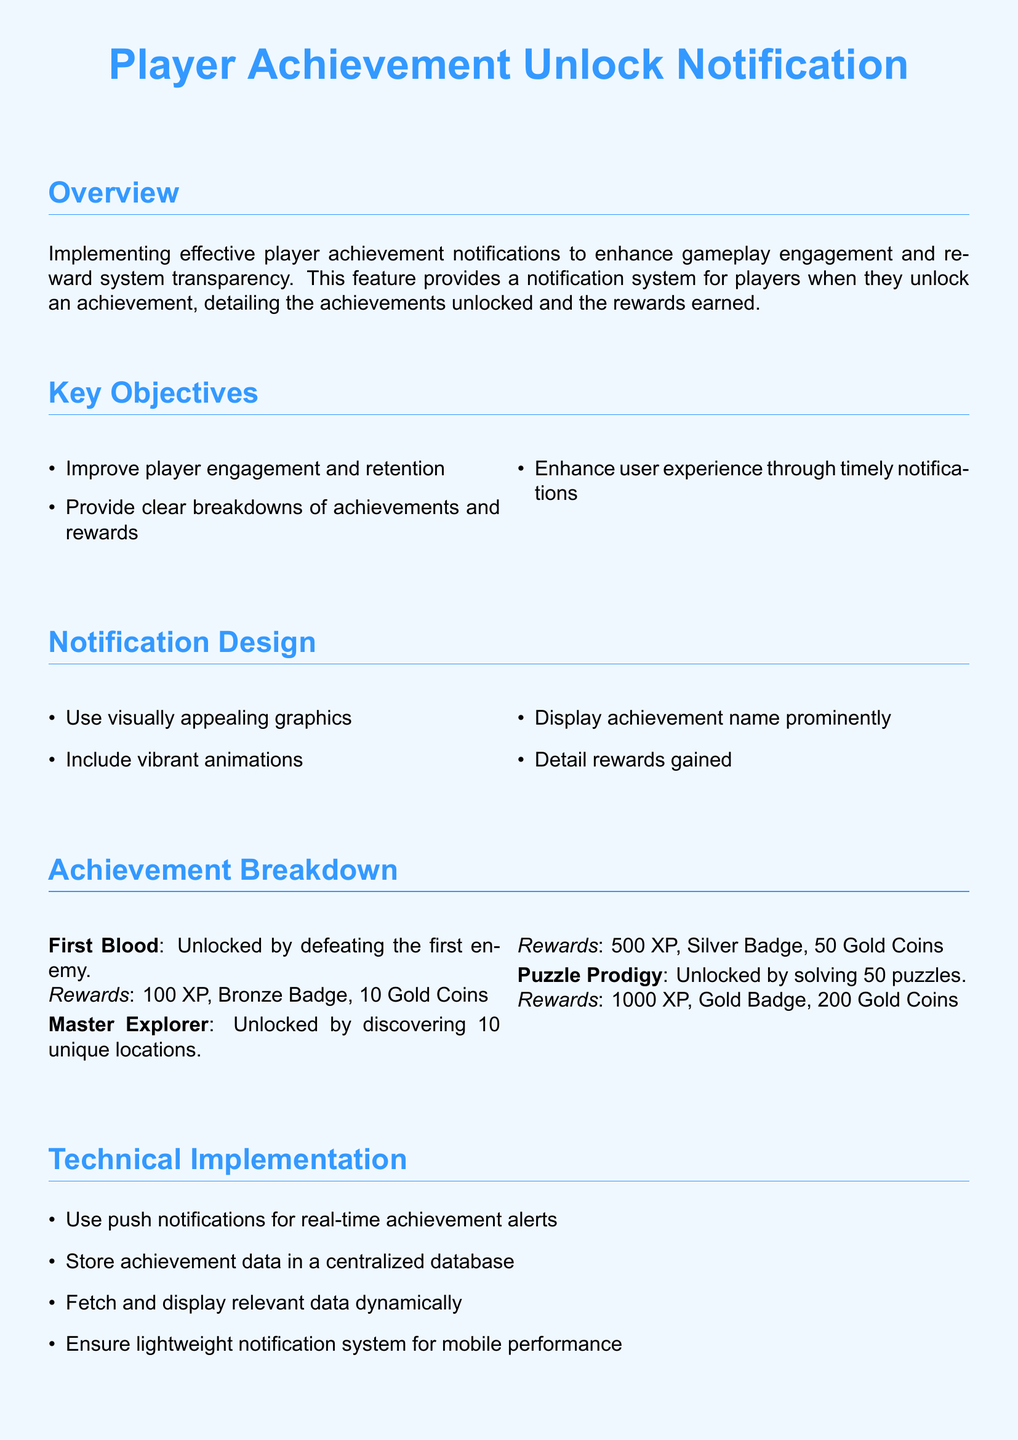What is the title of the document? The title of the document is prominently displayed at the top and indicates the main focus of the content.
Answer: Player Achievement Unlock Notification What is the achievement for discovering 10 unique locations? This question asks for a specific achievement listed in the document under Achievement Breakdown.
Answer: Master Explorer How many Gold Coins do players receive for unlocking the "First Blood" achievement? This question requires retrieving the specific reward associated with a particular achievement mentioned in the document.
Answer: 10 Gold Coins What is the XP reward for completing the "Puzzle Prodigy" achievement? This question looks for information regarding the experience points (XP) linked to a specific achievement in the document.
Answer: 1000 XP What design element is mentioned to enhance user experience? This question requires identifying a specific user experience enhancement mentioned in the notification design section of the document.
Answer: Vibrant animations How many total achievements are detailed in the Achievement Breakdown? This question involves counting the individual achievements listed under the Achievement Breakdown section.
Answer: 3 What type of notification system is recommended for real-time achievement alerts? This question asks for the specific type of system suggested in the technical implementation section.
Answer: Push notifications Which badge is awarded for the "Master Explorer" achievement? This question probes for specific achievement details listed in the document regarding the type of badge rewarded.
Answer: Silver Badge What is the document type of this content? This question is focused on what kind of document this specifically is, based on its format and purpose.
Answer: Ticket 